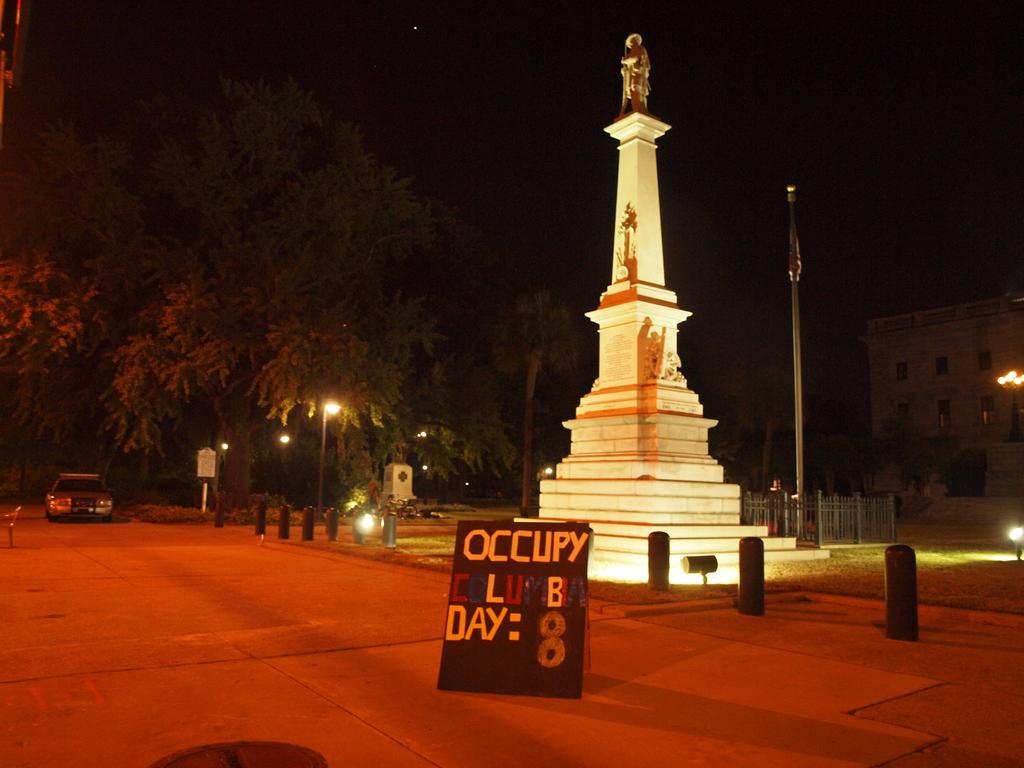How many number 8 can you see?
Offer a very short reply. 1. 